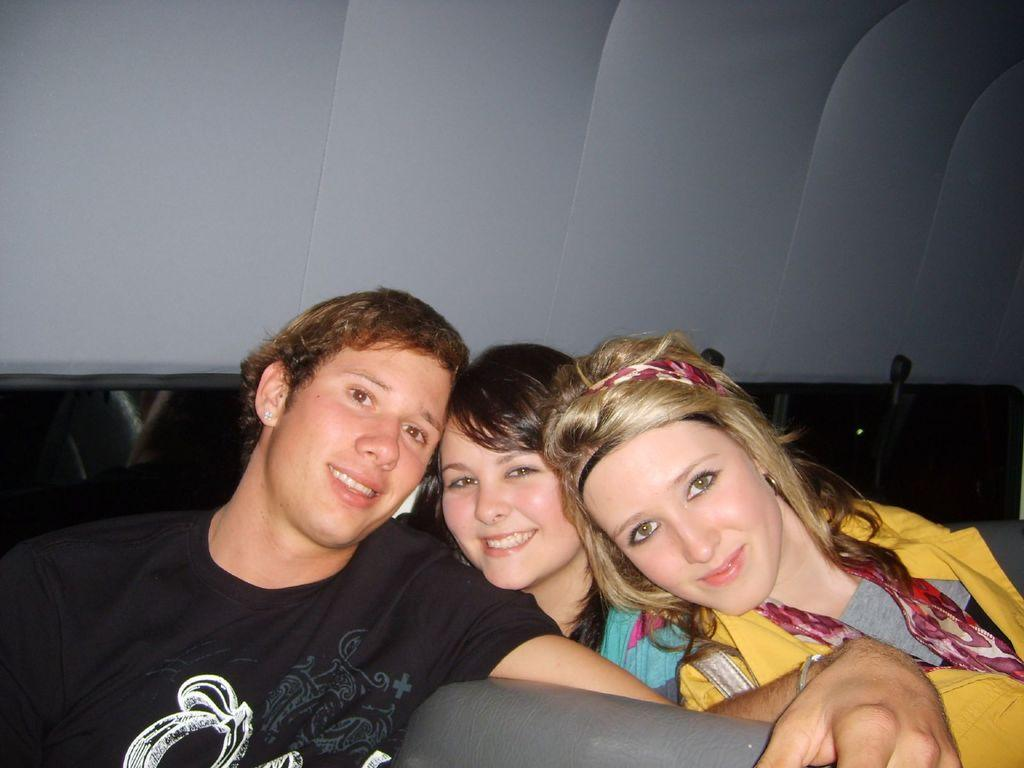How many people are in the image? There are three people in the image. Can you describe the gender of the people in the image? One of the people is a man, and two of the people are women. What are the people in the image doing? All three people are posing for a photo. What expressions do the people have in the image? All three people are smiling. What type of milk can be seen in the image? There is no milk present in the image. How many eggs are visible in the image? There are no eggs visible in the image. 